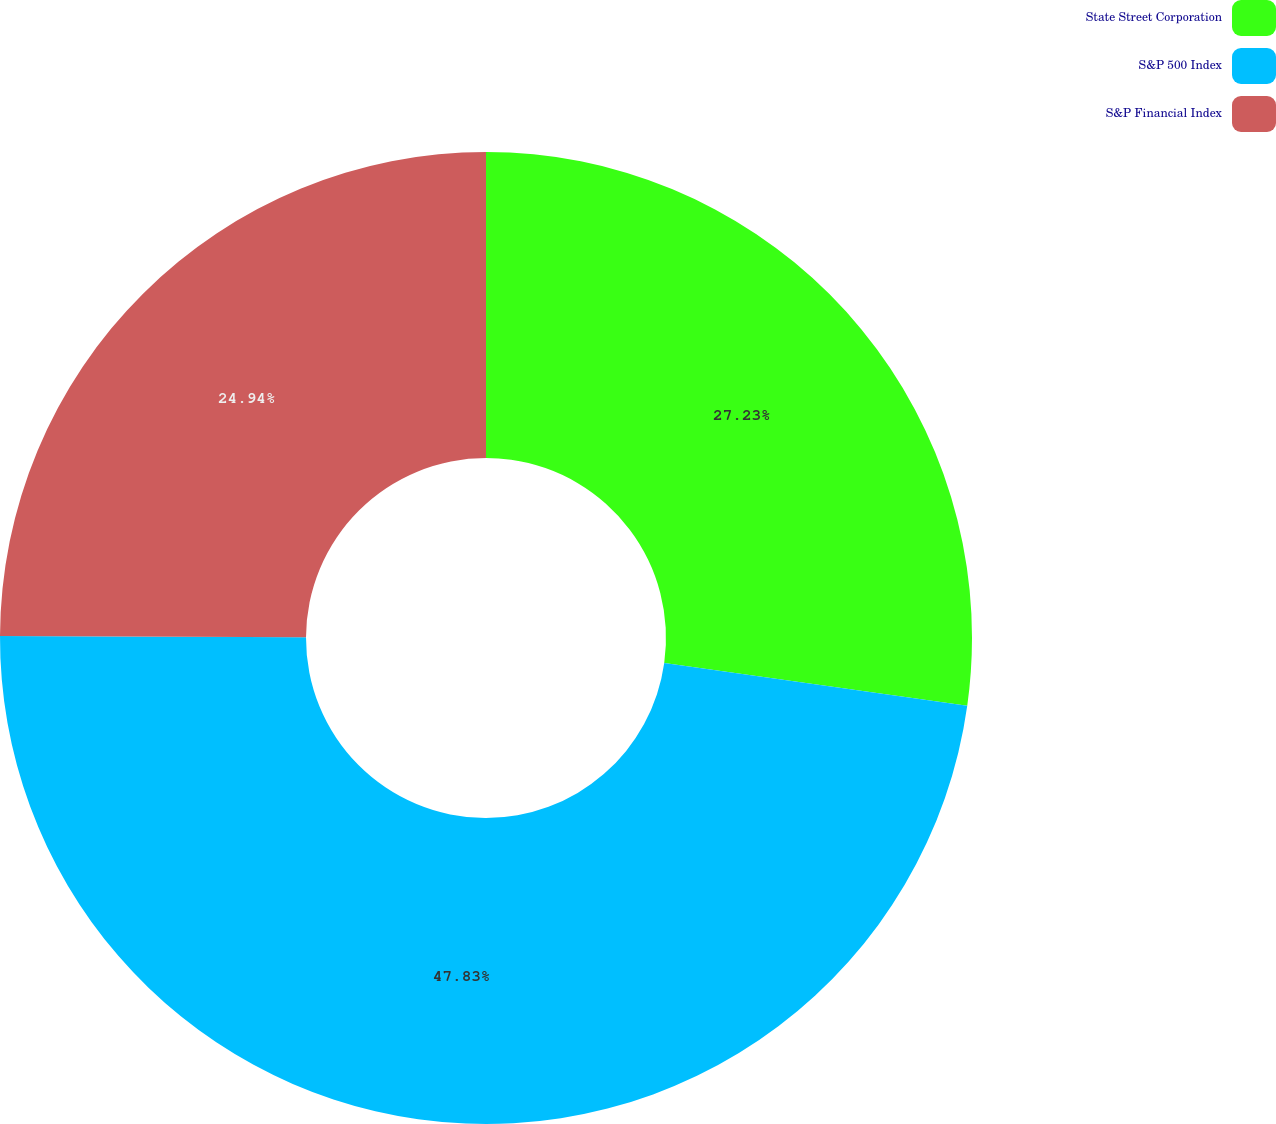Convert chart. <chart><loc_0><loc_0><loc_500><loc_500><pie_chart><fcel>State Street Corporation<fcel>S&P 500 Index<fcel>S&P Financial Index<nl><fcel>27.23%<fcel>47.84%<fcel>24.94%<nl></chart> 